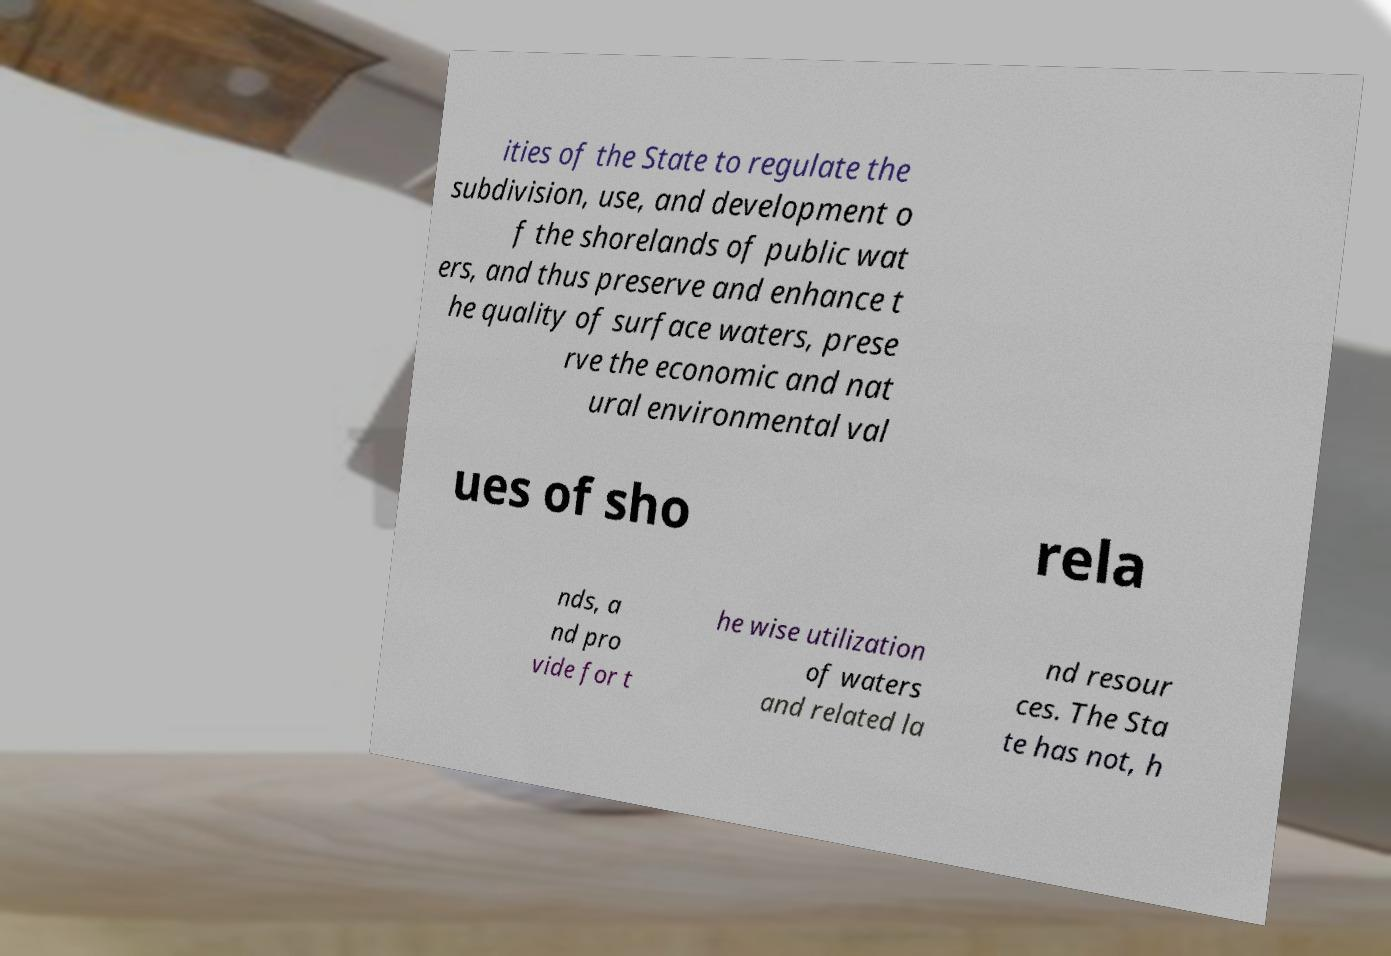I need the written content from this picture converted into text. Can you do that? ities of the State to regulate the subdivision, use, and development o f the shorelands of public wat ers, and thus preserve and enhance t he quality of surface waters, prese rve the economic and nat ural environmental val ues of sho rela nds, a nd pro vide for t he wise utilization of waters and related la nd resour ces. The Sta te has not, h 